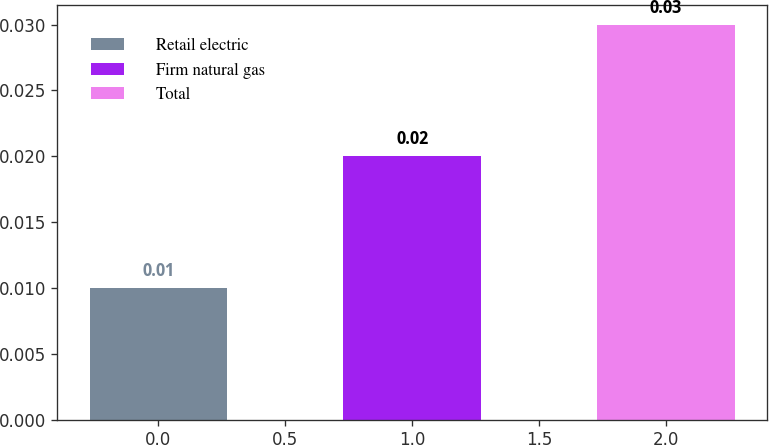<chart> <loc_0><loc_0><loc_500><loc_500><bar_chart><fcel>Retail electric<fcel>Firm natural gas<fcel>Total<nl><fcel>0.01<fcel>0.02<fcel>0.03<nl></chart> 